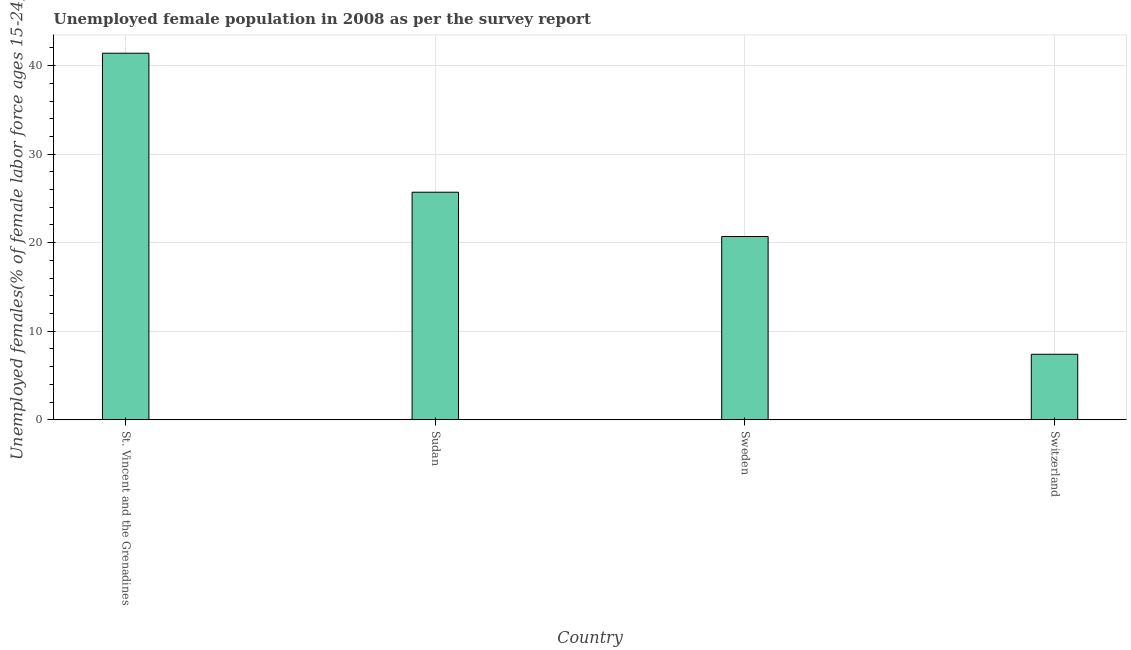Does the graph contain grids?
Make the answer very short. Yes. What is the title of the graph?
Your answer should be compact. Unemployed female population in 2008 as per the survey report. What is the label or title of the Y-axis?
Your response must be concise. Unemployed females(% of female labor force ages 15-24). What is the unemployed female youth in Sudan?
Offer a very short reply. 25.7. Across all countries, what is the maximum unemployed female youth?
Offer a terse response. 41.4. Across all countries, what is the minimum unemployed female youth?
Provide a succinct answer. 7.4. In which country was the unemployed female youth maximum?
Keep it short and to the point. St. Vincent and the Grenadines. In which country was the unemployed female youth minimum?
Your response must be concise. Switzerland. What is the sum of the unemployed female youth?
Offer a terse response. 95.2. What is the difference between the unemployed female youth in Sudan and Sweden?
Offer a very short reply. 5. What is the average unemployed female youth per country?
Keep it short and to the point. 23.8. What is the median unemployed female youth?
Your response must be concise. 23.2. In how many countries, is the unemployed female youth greater than 8 %?
Provide a short and direct response. 3. What is the ratio of the unemployed female youth in Sudan to that in Switzerland?
Your response must be concise. 3.47. Is the unemployed female youth in St. Vincent and the Grenadines less than that in Sudan?
Provide a short and direct response. No. What is the difference between the highest and the lowest unemployed female youth?
Your answer should be very brief. 34. In how many countries, is the unemployed female youth greater than the average unemployed female youth taken over all countries?
Your answer should be very brief. 2. How many bars are there?
Your answer should be compact. 4. Are all the bars in the graph horizontal?
Your answer should be compact. No. What is the difference between two consecutive major ticks on the Y-axis?
Keep it short and to the point. 10. What is the Unemployed females(% of female labor force ages 15-24) of St. Vincent and the Grenadines?
Ensure brevity in your answer.  41.4. What is the Unemployed females(% of female labor force ages 15-24) of Sudan?
Make the answer very short. 25.7. What is the Unemployed females(% of female labor force ages 15-24) of Sweden?
Provide a succinct answer. 20.7. What is the Unemployed females(% of female labor force ages 15-24) in Switzerland?
Your answer should be compact. 7.4. What is the difference between the Unemployed females(% of female labor force ages 15-24) in St. Vincent and the Grenadines and Sweden?
Your response must be concise. 20.7. What is the difference between the Unemployed females(% of female labor force ages 15-24) in Sudan and Switzerland?
Keep it short and to the point. 18.3. What is the ratio of the Unemployed females(% of female labor force ages 15-24) in St. Vincent and the Grenadines to that in Sudan?
Make the answer very short. 1.61. What is the ratio of the Unemployed females(% of female labor force ages 15-24) in St. Vincent and the Grenadines to that in Sweden?
Keep it short and to the point. 2. What is the ratio of the Unemployed females(% of female labor force ages 15-24) in St. Vincent and the Grenadines to that in Switzerland?
Keep it short and to the point. 5.59. What is the ratio of the Unemployed females(% of female labor force ages 15-24) in Sudan to that in Sweden?
Give a very brief answer. 1.24. What is the ratio of the Unemployed females(% of female labor force ages 15-24) in Sudan to that in Switzerland?
Provide a short and direct response. 3.47. What is the ratio of the Unemployed females(% of female labor force ages 15-24) in Sweden to that in Switzerland?
Give a very brief answer. 2.8. 